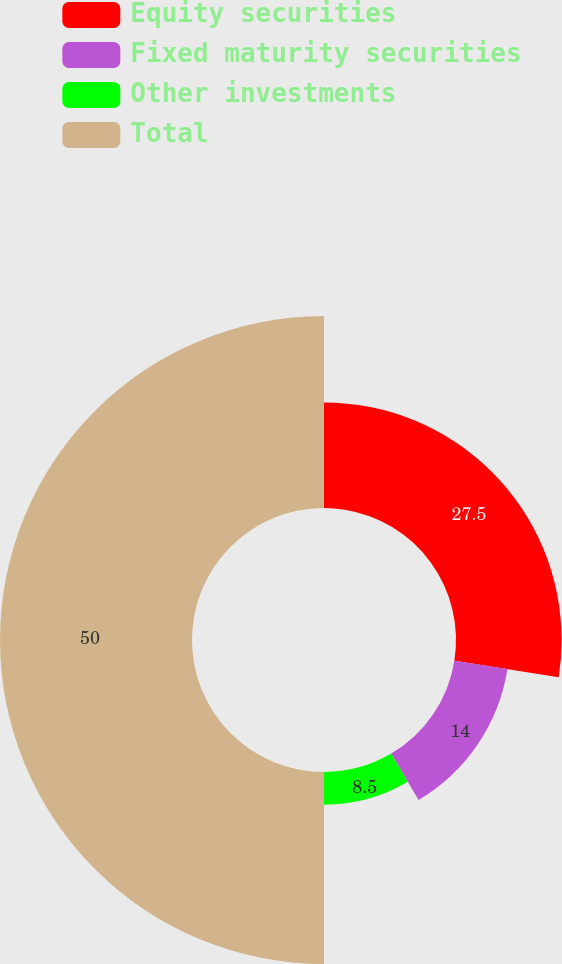<chart> <loc_0><loc_0><loc_500><loc_500><pie_chart><fcel>Equity securities<fcel>Fixed maturity securities<fcel>Other investments<fcel>Total<nl><fcel>27.5%<fcel>14.0%<fcel>8.5%<fcel>50.0%<nl></chart> 